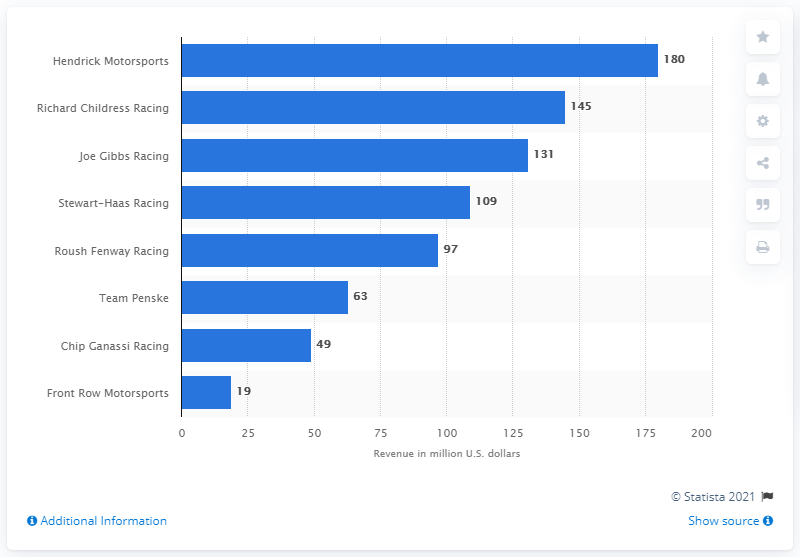Outline some significant characteristics in this image. In 2017, Hendrick Motorsports generated a revenue of 180 million dollars, making it one of the most successful NASCAR teams in terms of financial performance. In 2017, Hendrick Motorsports generated approximately 180 million dollars in revenue. 